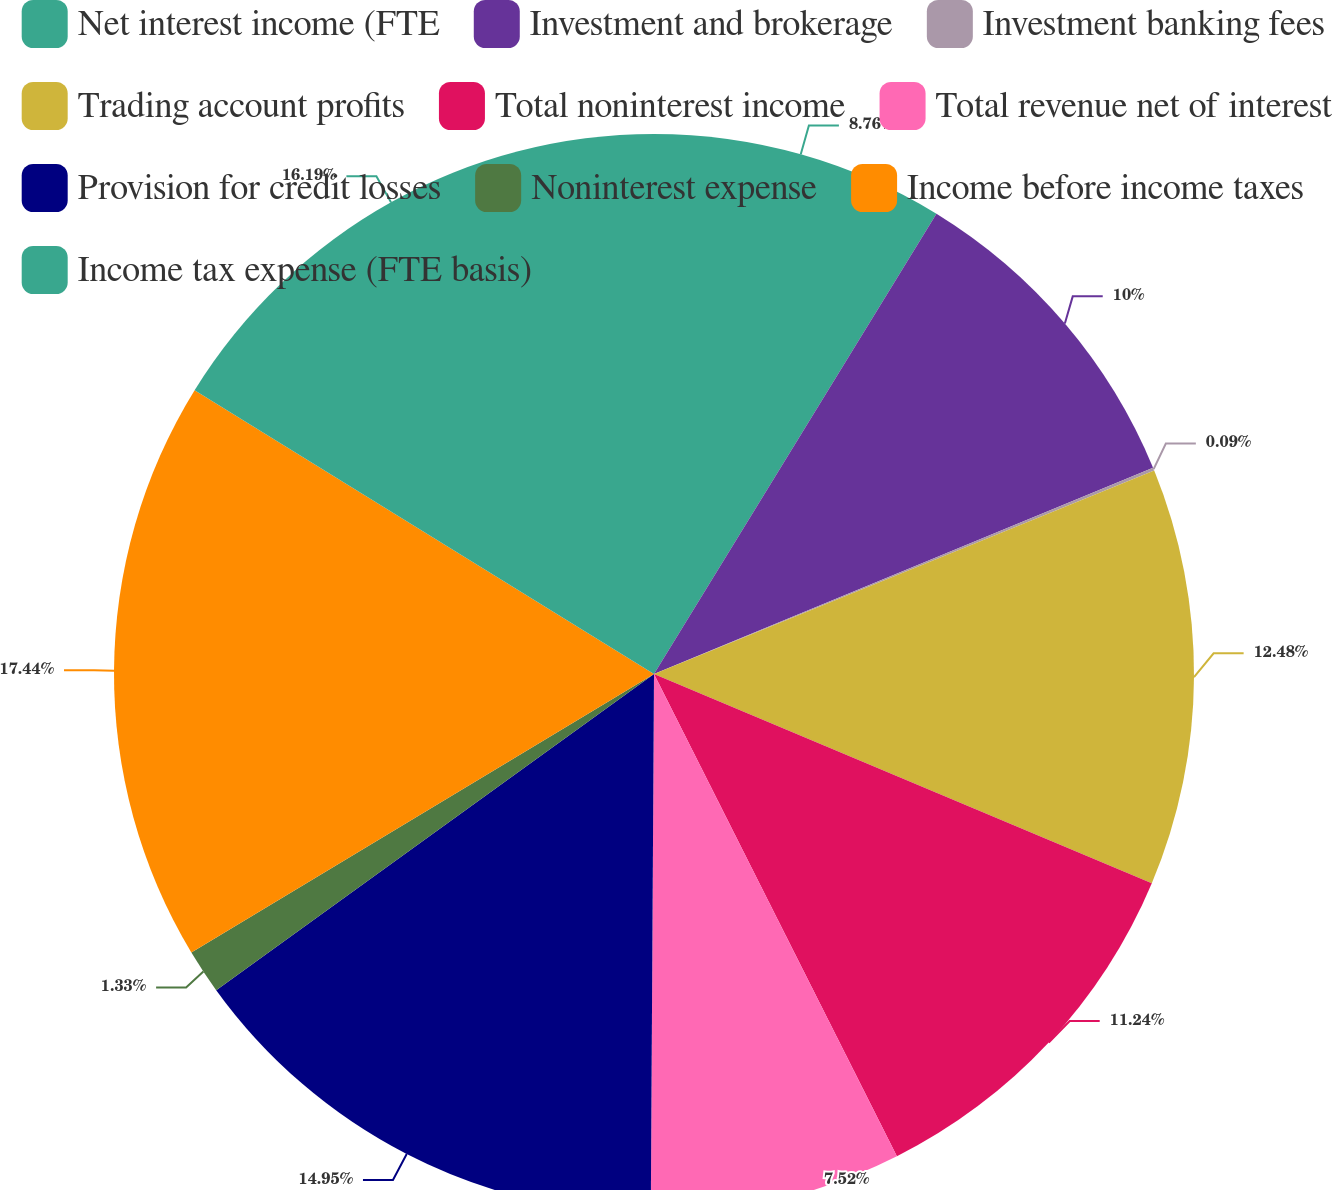Convert chart to OTSL. <chart><loc_0><loc_0><loc_500><loc_500><pie_chart><fcel>Net interest income (FTE<fcel>Investment and brokerage<fcel>Investment banking fees<fcel>Trading account profits<fcel>Total noninterest income<fcel>Total revenue net of interest<fcel>Provision for credit losses<fcel>Noninterest expense<fcel>Income before income taxes<fcel>Income tax expense (FTE basis)<nl><fcel>8.76%<fcel>10.0%<fcel>0.09%<fcel>12.48%<fcel>11.24%<fcel>7.52%<fcel>14.95%<fcel>1.33%<fcel>17.43%<fcel>16.19%<nl></chart> 